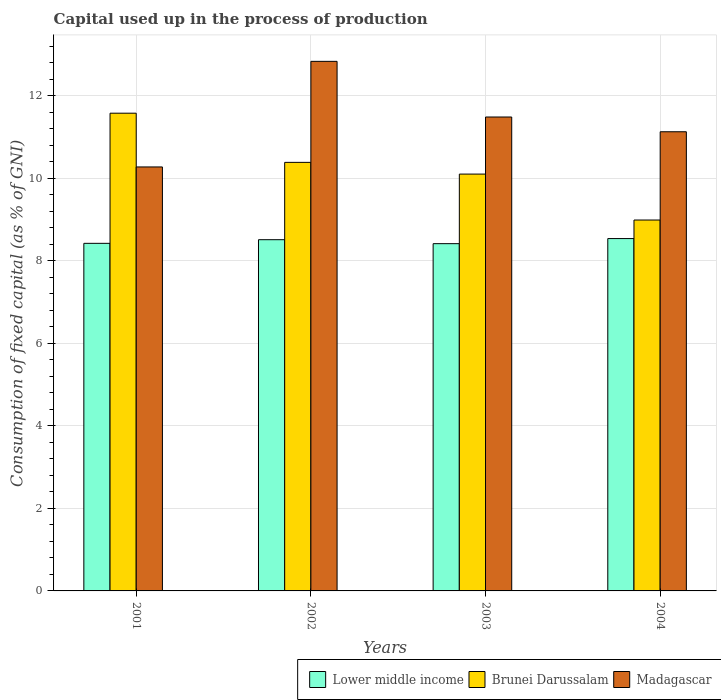How many groups of bars are there?
Provide a short and direct response. 4. Are the number of bars on each tick of the X-axis equal?
Offer a very short reply. Yes. What is the label of the 1st group of bars from the left?
Your answer should be very brief. 2001. In how many cases, is the number of bars for a given year not equal to the number of legend labels?
Provide a short and direct response. 0. What is the capital used up in the process of production in Lower middle income in 2001?
Offer a terse response. 8.43. Across all years, what is the maximum capital used up in the process of production in Brunei Darussalam?
Keep it short and to the point. 11.58. Across all years, what is the minimum capital used up in the process of production in Brunei Darussalam?
Make the answer very short. 8.99. In which year was the capital used up in the process of production in Lower middle income minimum?
Provide a succinct answer. 2003. What is the total capital used up in the process of production in Brunei Darussalam in the graph?
Make the answer very short. 41.07. What is the difference between the capital used up in the process of production in Brunei Darussalam in 2002 and that in 2004?
Make the answer very short. 1.4. What is the difference between the capital used up in the process of production in Lower middle income in 2002 and the capital used up in the process of production in Brunei Darussalam in 2004?
Give a very brief answer. -0.48. What is the average capital used up in the process of production in Madagascar per year?
Ensure brevity in your answer.  11.43. In the year 2004, what is the difference between the capital used up in the process of production in Lower middle income and capital used up in the process of production in Madagascar?
Ensure brevity in your answer.  -2.59. In how many years, is the capital used up in the process of production in Madagascar greater than 9.6 %?
Offer a terse response. 4. What is the ratio of the capital used up in the process of production in Lower middle income in 2002 to that in 2003?
Offer a very short reply. 1.01. Is the capital used up in the process of production in Brunei Darussalam in 2002 less than that in 2004?
Keep it short and to the point. No. What is the difference between the highest and the second highest capital used up in the process of production in Brunei Darussalam?
Your answer should be compact. 1.19. What is the difference between the highest and the lowest capital used up in the process of production in Brunei Darussalam?
Offer a terse response. 2.59. What does the 1st bar from the left in 2002 represents?
Ensure brevity in your answer.  Lower middle income. What does the 2nd bar from the right in 2002 represents?
Your answer should be compact. Brunei Darussalam. Is it the case that in every year, the sum of the capital used up in the process of production in Lower middle income and capital used up in the process of production in Madagascar is greater than the capital used up in the process of production in Brunei Darussalam?
Give a very brief answer. Yes. How many bars are there?
Keep it short and to the point. 12. How many years are there in the graph?
Ensure brevity in your answer.  4. Are the values on the major ticks of Y-axis written in scientific E-notation?
Ensure brevity in your answer.  No. Does the graph contain any zero values?
Make the answer very short. No. Does the graph contain grids?
Your response must be concise. Yes. Where does the legend appear in the graph?
Give a very brief answer. Bottom right. What is the title of the graph?
Provide a succinct answer. Capital used up in the process of production. Does "Bahrain" appear as one of the legend labels in the graph?
Your response must be concise. No. What is the label or title of the Y-axis?
Ensure brevity in your answer.  Consumption of fixed capital (as % of GNI). What is the Consumption of fixed capital (as % of GNI) in Lower middle income in 2001?
Your response must be concise. 8.43. What is the Consumption of fixed capital (as % of GNI) in Brunei Darussalam in 2001?
Provide a short and direct response. 11.58. What is the Consumption of fixed capital (as % of GNI) in Madagascar in 2001?
Offer a terse response. 10.28. What is the Consumption of fixed capital (as % of GNI) of Lower middle income in 2002?
Your answer should be compact. 8.51. What is the Consumption of fixed capital (as % of GNI) of Brunei Darussalam in 2002?
Your response must be concise. 10.39. What is the Consumption of fixed capital (as % of GNI) of Madagascar in 2002?
Keep it short and to the point. 12.84. What is the Consumption of fixed capital (as % of GNI) in Lower middle income in 2003?
Your response must be concise. 8.42. What is the Consumption of fixed capital (as % of GNI) in Brunei Darussalam in 2003?
Provide a succinct answer. 10.11. What is the Consumption of fixed capital (as % of GNI) of Madagascar in 2003?
Keep it short and to the point. 11.49. What is the Consumption of fixed capital (as % of GNI) in Lower middle income in 2004?
Offer a very short reply. 8.54. What is the Consumption of fixed capital (as % of GNI) of Brunei Darussalam in 2004?
Ensure brevity in your answer.  8.99. What is the Consumption of fixed capital (as % of GNI) in Madagascar in 2004?
Offer a terse response. 11.13. Across all years, what is the maximum Consumption of fixed capital (as % of GNI) of Lower middle income?
Give a very brief answer. 8.54. Across all years, what is the maximum Consumption of fixed capital (as % of GNI) of Brunei Darussalam?
Offer a very short reply. 11.58. Across all years, what is the maximum Consumption of fixed capital (as % of GNI) of Madagascar?
Your answer should be very brief. 12.84. Across all years, what is the minimum Consumption of fixed capital (as % of GNI) of Lower middle income?
Make the answer very short. 8.42. Across all years, what is the minimum Consumption of fixed capital (as % of GNI) of Brunei Darussalam?
Make the answer very short. 8.99. Across all years, what is the minimum Consumption of fixed capital (as % of GNI) of Madagascar?
Keep it short and to the point. 10.28. What is the total Consumption of fixed capital (as % of GNI) of Lower middle income in the graph?
Make the answer very short. 33.9. What is the total Consumption of fixed capital (as % of GNI) of Brunei Darussalam in the graph?
Your answer should be very brief. 41.07. What is the total Consumption of fixed capital (as % of GNI) of Madagascar in the graph?
Provide a short and direct response. 45.74. What is the difference between the Consumption of fixed capital (as % of GNI) of Lower middle income in 2001 and that in 2002?
Ensure brevity in your answer.  -0.09. What is the difference between the Consumption of fixed capital (as % of GNI) of Brunei Darussalam in 2001 and that in 2002?
Provide a succinct answer. 1.19. What is the difference between the Consumption of fixed capital (as % of GNI) in Madagascar in 2001 and that in 2002?
Keep it short and to the point. -2.56. What is the difference between the Consumption of fixed capital (as % of GNI) of Lower middle income in 2001 and that in 2003?
Offer a terse response. 0.01. What is the difference between the Consumption of fixed capital (as % of GNI) in Brunei Darussalam in 2001 and that in 2003?
Offer a terse response. 1.48. What is the difference between the Consumption of fixed capital (as % of GNI) of Madagascar in 2001 and that in 2003?
Your answer should be compact. -1.21. What is the difference between the Consumption of fixed capital (as % of GNI) of Lower middle income in 2001 and that in 2004?
Provide a succinct answer. -0.12. What is the difference between the Consumption of fixed capital (as % of GNI) of Brunei Darussalam in 2001 and that in 2004?
Offer a terse response. 2.59. What is the difference between the Consumption of fixed capital (as % of GNI) of Madagascar in 2001 and that in 2004?
Offer a terse response. -0.85. What is the difference between the Consumption of fixed capital (as % of GNI) of Lower middle income in 2002 and that in 2003?
Offer a very short reply. 0.1. What is the difference between the Consumption of fixed capital (as % of GNI) of Brunei Darussalam in 2002 and that in 2003?
Your answer should be very brief. 0.28. What is the difference between the Consumption of fixed capital (as % of GNI) in Madagascar in 2002 and that in 2003?
Ensure brevity in your answer.  1.35. What is the difference between the Consumption of fixed capital (as % of GNI) in Lower middle income in 2002 and that in 2004?
Make the answer very short. -0.03. What is the difference between the Consumption of fixed capital (as % of GNI) of Brunei Darussalam in 2002 and that in 2004?
Your answer should be compact. 1.4. What is the difference between the Consumption of fixed capital (as % of GNI) in Madagascar in 2002 and that in 2004?
Provide a short and direct response. 1.71. What is the difference between the Consumption of fixed capital (as % of GNI) in Lower middle income in 2003 and that in 2004?
Offer a terse response. -0.12. What is the difference between the Consumption of fixed capital (as % of GNI) in Brunei Darussalam in 2003 and that in 2004?
Provide a short and direct response. 1.11. What is the difference between the Consumption of fixed capital (as % of GNI) of Madagascar in 2003 and that in 2004?
Provide a succinct answer. 0.36. What is the difference between the Consumption of fixed capital (as % of GNI) of Lower middle income in 2001 and the Consumption of fixed capital (as % of GNI) of Brunei Darussalam in 2002?
Provide a short and direct response. -1.96. What is the difference between the Consumption of fixed capital (as % of GNI) in Lower middle income in 2001 and the Consumption of fixed capital (as % of GNI) in Madagascar in 2002?
Your response must be concise. -4.41. What is the difference between the Consumption of fixed capital (as % of GNI) of Brunei Darussalam in 2001 and the Consumption of fixed capital (as % of GNI) of Madagascar in 2002?
Your answer should be compact. -1.26. What is the difference between the Consumption of fixed capital (as % of GNI) in Lower middle income in 2001 and the Consumption of fixed capital (as % of GNI) in Brunei Darussalam in 2003?
Provide a short and direct response. -1.68. What is the difference between the Consumption of fixed capital (as % of GNI) of Lower middle income in 2001 and the Consumption of fixed capital (as % of GNI) of Madagascar in 2003?
Make the answer very short. -3.06. What is the difference between the Consumption of fixed capital (as % of GNI) of Brunei Darussalam in 2001 and the Consumption of fixed capital (as % of GNI) of Madagascar in 2003?
Provide a short and direct response. 0.09. What is the difference between the Consumption of fixed capital (as % of GNI) of Lower middle income in 2001 and the Consumption of fixed capital (as % of GNI) of Brunei Darussalam in 2004?
Your answer should be compact. -0.57. What is the difference between the Consumption of fixed capital (as % of GNI) in Lower middle income in 2001 and the Consumption of fixed capital (as % of GNI) in Madagascar in 2004?
Make the answer very short. -2.71. What is the difference between the Consumption of fixed capital (as % of GNI) in Brunei Darussalam in 2001 and the Consumption of fixed capital (as % of GNI) in Madagascar in 2004?
Make the answer very short. 0.45. What is the difference between the Consumption of fixed capital (as % of GNI) of Lower middle income in 2002 and the Consumption of fixed capital (as % of GNI) of Brunei Darussalam in 2003?
Offer a very short reply. -1.59. What is the difference between the Consumption of fixed capital (as % of GNI) of Lower middle income in 2002 and the Consumption of fixed capital (as % of GNI) of Madagascar in 2003?
Make the answer very short. -2.97. What is the difference between the Consumption of fixed capital (as % of GNI) in Brunei Darussalam in 2002 and the Consumption of fixed capital (as % of GNI) in Madagascar in 2003?
Offer a very short reply. -1.1. What is the difference between the Consumption of fixed capital (as % of GNI) of Lower middle income in 2002 and the Consumption of fixed capital (as % of GNI) of Brunei Darussalam in 2004?
Keep it short and to the point. -0.48. What is the difference between the Consumption of fixed capital (as % of GNI) in Lower middle income in 2002 and the Consumption of fixed capital (as % of GNI) in Madagascar in 2004?
Your response must be concise. -2.62. What is the difference between the Consumption of fixed capital (as % of GNI) in Brunei Darussalam in 2002 and the Consumption of fixed capital (as % of GNI) in Madagascar in 2004?
Provide a short and direct response. -0.74. What is the difference between the Consumption of fixed capital (as % of GNI) in Lower middle income in 2003 and the Consumption of fixed capital (as % of GNI) in Brunei Darussalam in 2004?
Provide a succinct answer. -0.57. What is the difference between the Consumption of fixed capital (as % of GNI) of Lower middle income in 2003 and the Consumption of fixed capital (as % of GNI) of Madagascar in 2004?
Keep it short and to the point. -2.71. What is the difference between the Consumption of fixed capital (as % of GNI) in Brunei Darussalam in 2003 and the Consumption of fixed capital (as % of GNI) in Madagascar in 2004?
Ensure brevity in your answer.  -1.03. What is the average Consumption of fixed capital (as % of GNI) in Lower middle income per year?
Provide a succinct answer. 8.48. What is the average Consumption of fixed capital (as % of GNI) of Brunei Darussalam per year?
Your response must be concise. 10.27. What is the average Consumption of fixed capital (as % of GNI) in Madagascar per year?
Give a very brief answer. 11.43. In the year 2001, what is the difference between the Consumption of fixed capital (as % of GNI) in Lower middle income and Consumption of fixed capital (as % of GNI) in Brunei Darussalam?
Your answer should be compact. -3.16. In the year 2001, what is the difference between the Consumption of fixed capital (as % of GNI) in Lower middle income and Consumption of fixed capital (as % of GNI) in Madagascar?
Your answer should be very brief. -1.85. In the year 2001, what is the difference between the Consumption of fixed capital (as % of GNI) in Brunei Darussalam and Consumption of fixed capital (as % of GNI) in Madagascar?
Provide a short and direct response. 1.3. In the year 2002, what is the difference between the Consumption of fixed capital (as % of GNI) of Lower middle income and Consumption of fixed capital (as % of GNI) of Brunei Darussalam?
Make the answer very short. -1.87. In the year 2002, what is the difference between the Consumption of fixed capital (as % of GNI) in Lower middle income and Consumption of fixed capital (as % of GNI) in Madagascar?
Your answer should be very brief. -4.32. In the year 2002, what is the difference between the Consumption of fixed capital (as % of GNI) of Brunei Darussalam and Consumption of fixed capital (as % of GNI) of Madagascar?
Your response must be concise. -2.45. In the year 2003, what is the difference between the Consumption of fixed capital (as % of GNI) of Lower middle income and Consumption of fixed capital (as % of GNI) of Brunei Darussalam?
Your answer should be very brief. -1.69. In the year 2003, what is the difference between the Consumption of fixed capital (as % of GNI) in Lower middle income and Consumption of fixed capital (as % of GNI) in Madagascar?
Ensure brevity in your answer.  -3.07. In the year 2003, what is the difference between the Consumption of fixed capital (as % of GNI) of Brunei Darussalam and Consumption of fixed capital (as % of GNI) of Madagascar?
Your answer should be compact. -1.38. In the year 2004, what is the difference between the Consumption of fixed capital (as % of GNI) of Lower middle income and Consumption of fixed capital (as % of GNI) of Brunei Darussalam?
Provide a short and direct response. -0.45. In the year 2004, what is the difference between the Consumption of fixed capital (as % of GNI) in Lower middle income and Consumption of fixed capital (as % of GNI) in Madagascar?
Keep it short and to the point. -2.59. In the year 2004, what is the difference between the Consumption of fixed capital (as % of GNI) of Brunei Darussalam and Consumption of fixed capital (as % of GNI) of Madagascar?
Offer a very short reply. -2.14. What is the ratio of the Consumption of fixed capital (as % of GNI) in Brunei Darussalam in 2001 to that in 2002?
Provide a short and direct response. 1.11. What is the ratio of the Consumption of fixed capital (as % of GNI) in Madagascar in 2001 to that in 2002?
Keep it short and to the point. 0.8. What is the ratio of the Consumption of fixed capital (as % of GNI) of Brunei Darussalam in 2001 to that in 2003?
Your answer should be compact. 1.15. What is the ratio of the Consumption of fixed capital (as % of GNI) of Madagascar in 2001 to that in 2003?
Provide a short and direct response. 0.89. What is the ratio of the Consumption of fixed capital (as % of GNI) of Lower middle income in 2001 to that in 2004?
Make the answer very short. 0.99. What is the ratio of the Consumption of fixed capital (as % of GNI) in Brunei Darussalam in 2001 to that in 2004?
Provide a short and direct response. 1.29. What is the ratio of the Consumption of fixed capital (as % of GNI) of Madagascar in 2001 to that in 2004?
Keep it short and to the point. 0.92. What is the ratio of the Consumption of fixed capital (as % of GNI) of Lower middle income in 2002 to that in 2003?
Your answer should be compact. 1.01. What is the ratio of the Consumption of fixed capital (as % of GNI) of Brunei Darussalam in 2002 to that in 2003?
Your answer should be compact. 1.03. What is the ratio of the Consumption of fixed capital (as % of GNI) of Madagascar in 2002 to that in 2003?
Provide a short and direct response. 1.12. What is the ratio of the Consumption of fixed capital (as % of GNI) in Brunei Darussalam in 2002 to that in 2004?
Give a very brief answer. 1.16. What is the ratio of the Consumption of fixed capital (as % of GNI) in Madagascar in 2002 to that in 2004?
Your answer should be very brief. 1.15. What is the ratio of the Consumption of fixed capital (as % of GNI) in Lower middle income in 2003 to that in 2004?
Your response must be concise. 0.99. What is the ratio of the Consumption of fixed capital (as % of GNI) of Brunei Darussalam in 2003 to that in 2004?
Your answer should be very brief. 1.12. What is the ratio of the Consumption of fixed capital (as % of GNI) in Madagascar in 2003 to that in 2004?
Offer a very short reply. 1.03. What is the difference between the highest and the second highest Consumption of fixed capital (as % of GNI) in Lower middle income?
Your response must be concise. 0.03. What is the difference between the highest and the second highest Consumption of fixed capital (as % of GNI) in Brunei Darussalam?
Provide a short and direct response. 1.19. What is the difference between the highest and the second highest Consumption of fixed capital (as % of GNI) of Madagascar?
Offer a terse response. 1.35. What is the difference between the highest and the lowest Consumption of fixed capital (as % of GNI) of Lower middle income?
Offer a terse response. 0.12. What is the difference between the highest and the lowest Consumption of fixed capital (as % of GNI) in Brunei Darussalam?
Keep it short and to the point. 2.59. What is the difference between the highest and the lowest Consumption of fixed capital (as % of GNI) in Madagascar?
Your answer should be very brief. 2.56. 